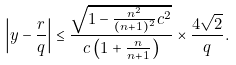<formula> <loc_0><loc_0><loc_500><loc_500>\left | y - \frac { r } { q } \right | \leq \frac { \sqrt { 1 - \frac { n ^ { 2 } } { ( n + 1 ) ^ { 2 } } c ^ { 2 } } } { c \left ( 1 + \frac { n } { n + 1 } \right ) } \times \frac { 4 \sqrt { 2 } } { q } .</formula> 